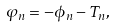Convert formula to latex. <formula><loc_0><loc_0><loc_500><loc_500>\varphi _ { n } = - \phi _ { n } - T _ { n } ,</formula> 